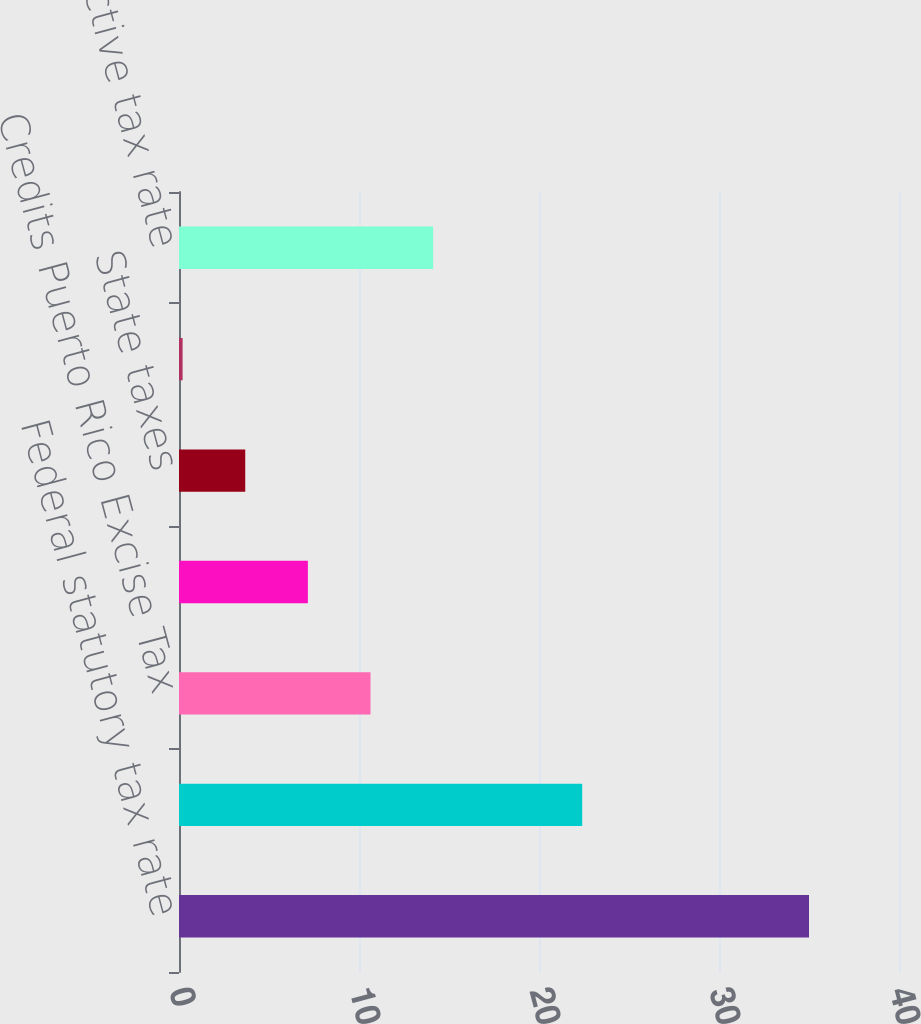<chart> <loc_0><loc_0><loc_500><loc_500><bar_chart><fcel>Federal statutory tax rate<fcel>Foreign earnings including<fcel>Credits Puerto Rico Excise Tax<fcel>Credits primarily federal R&D<fcel>State taxes<fcel>Other net<fcel>Effective tax rate<nl><fcel>35<fcel>22.4<fcel>10.64<fcel>7.16<fcel>3.68<fcel>0.2<fcel>14.12<nl></chart> 